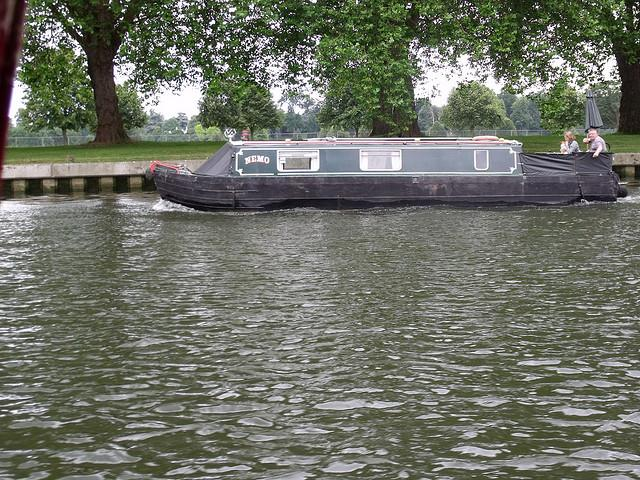What does the word on the boat relate? Please explain your reasoning. movie. Nemo was a film about a fish 